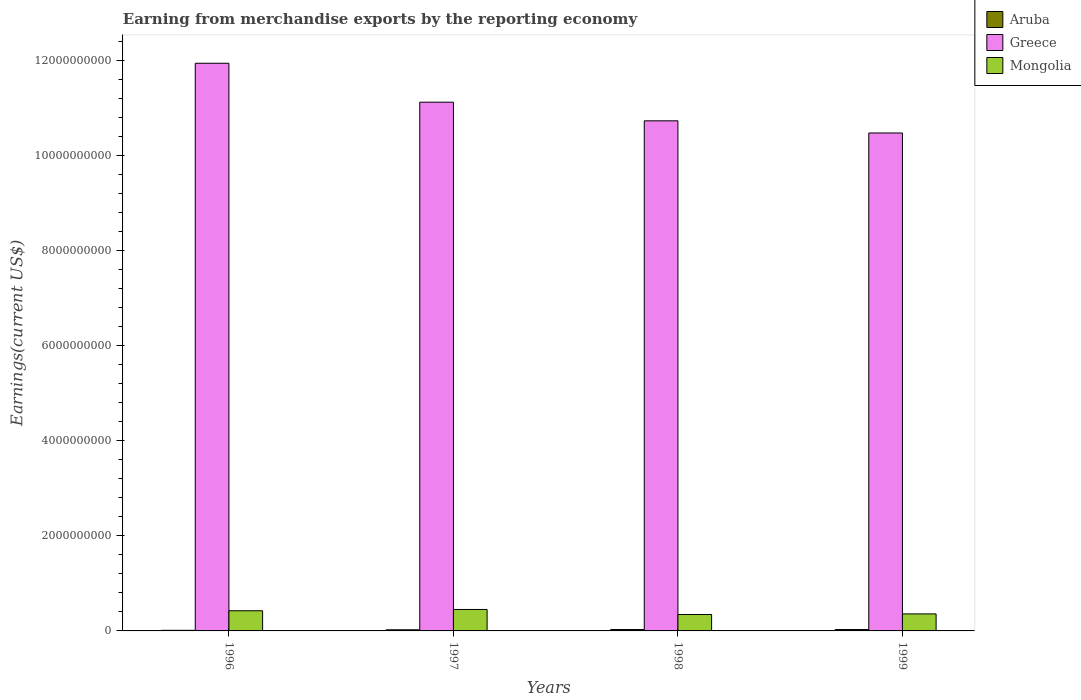Are the number of bars on each tick of the X-axis equal?
Your response must be concise. Yes. In how many cases, is the number of bars for a given year not equal to the number of legend labels?
Offer a terse response. 0. What is the amount earned from merchandise exports in Greece in 1999?
Keep it short and to the point. 1.05e+1. Across all years, what is the maximum amount earned from merchandise exports in Aruba?
Your response must be concise. 2.93e+07. Across all years, what is the minimum amount earned from merchandise exports in Mongolia?
Provide a short and direct response. 3.45e+08. What is the total amount earned from merchandise exports in Aruba in the graph?
Ensure brevity in your answer.  9.47e+07. What is the difference between the amount earned from merchandise exports in Aruba in 1996 and that in 1997?
Your answer should be very brief. -1.14e+07. What is the difference between the amount earned from merchandise exports in Aruba in 1998 and the amount earned from merchandise exports in Mongolia in 1999?
Ensure brevity in your answer.  -3.29e+08. What is the average amount earned from merchandise exports in Aruba per year?
Keep it short and to the point. 2.37e+07. In the year 1996, what is the difference between the amount earned from merchandise exports in Greece and amount earned from merchandise exports in Aruba?
Your answer should be compact. 1.19e+1. In how many years, is the amount earned from merchandise exports in Aruba greater than 1600000000 US$?
Ensure brevity in your answer.  0. What is the ratio of the amount earned from merchandise exports in Mongolia in 1996 to that in 1999?
Make the answer very short. 1.18. Is the difference between the amount earned from merchandise exports in Greece in 1996 and 1997 greater than the difference between the amount earned from merchandise exports in Aruba in 1996 and 1997?
Ensure brevity in your answer.  Yes. What is the difference between the highest and the second highest amount earned from merchandise exports in Mongolia?
Offer a terse response. 2.72e+07. What is the difference between the highest and the lowest amount earned from merchandise exports in Greece?
Keep it short and to the point. 1.47e+09. Is the sum of the amount earned from merchandise exports in Aruba in 1996 and 1997 greater than the maximum amount earned from merchandise exports in Greece across all years?
Your answer should be compact. No. What does the 2nd bar from the left in 1996 represents?
Make the answer very short. Greece. What does the 1st bar from the right in 1996 represents?
Ensure brevity in your answer.  Mongolia. How many bars are there?
Provide a succinct answer. 12. Are all the bars in the graph horizontal?
Your answer should be very brief. No. Are the values on the major ticks of Y-axis written in scientific E-notation?
Your answer should be very brief. No. How many legend labels are there?
Provide a short and direct response. 3. How are the legend labels stacked?
Provide a short and direct response. Vertical. What is the title of the graph?
Your response must be concise. Earning from merchandise exports by the reporting economy. Does "Kyrgyz Republic" appear as one of the legend labels in the graph?
Your response must be concise. No. What is the label or title of the Y-axis?
Keep it short and to the point. Earnings(current US$). What is the Earnings(current US$) of Aruba in 1996?
Your answer should be compact. 1.25e+07. What is the Earnings(current US$) of Greece in 1996?
Your response must be concise. 1.19e+1. What is the Earnings(current US$) in Mongolia in 1996?
Offer a very short reply. 4.24e+08. What is the Earnings(current US$) in Aruba in 1997?
Ensure brevity in your answer.  2.39e+07. What is the Earnings(current US$) in Greece in 1997?
Make the answer very short. 1.11e+1. What is the Earnings(current US$) in Mongolia in 1997?
Provide a short and direct response. 4.52e+08. What is the Earnings(current US$) in Aruba in 1998?
Your answer should be compact. 2.90e+07. What is the Earnings(current US$) of Greece in 1998?
Keep it short and to the point. 1.07e+1. What is the Earnings(current US$) of Mongolia in 1998?
Keep it short and to the point. 3.45e+08. What is the Earnings(current US$) of Aruba in 1999?
Your answer should be very brief. 2.93e+07. What is the Earnings(current US$) in Greece in 1999?
Give a very brief answer. 1.05e+1. What is the Earnings(current US$) in Mongolia in 1999?
Provide a short and direct response. 3.58e+08. Across all years, what is the maximum Earnings(current US$) of Aruba?
Your answer should be very brief. 2.93e+07. Across all years, what is the maximum Earnings(current US$) in Greece?
Provide a short and direct response. 1.19e+1. Across all years, what is the maximum Earnings(current US$) of Mongolia?
Offer a very short reply. 4.52e+08. Across all years, what is the minimum Earnings(current US$) of Aruba?
Offer a terse response. 1.25e+07. Across all years, what is the minimum Earnings(current US$) of Greece?
Give a very brief answer. 1.05e+1. Across all years, what is the minimum Earnings(current US$) of Mongolia?
Your answer should be very brief. 3.45e+08. What is the total Earnings(current US$) of Aruba in the graph?
Keep it short and to the point. 9.47e+07. What is the total Earnings(current US$) in Greece in the graph?
Provide a short and direct response. 4.43e+1. What is the total Earnings(current US$) in Mongolia in the graph?
Give a very brief answer. 1.58e+09. What is the difference between the Earnings(current US$) of Aruba in 1996 and that in 1997?
Provide a short and direct response. -1.14e+07. What is the difference between the Earnings(current US$) in Greece in 1996 and that in 1997?
Keep it short and to the point. 8.19e+08. What is the difference between the Earnings(current US$) of Mongolia in 1996 and that in 1997?
Provide a succinct answer. -2.72e+07. What is the difference between the Earnings(current US$) of Aruba in 1996 and that in 1998?
Your answer should be very brief. -1.65e+07. What is the difference between the Earnings(current US$) of Greece in 1996 and that in 1998?
Ensure brevity in your answer.  1.21e+09. What is the difference between the Earnings(current US$) of Mongolia in 1996 and that in 1998?
Ensure brevity in your answer.  7.92e+07. What is the difference between the Earnings(current US$) in Aruba in 1996 and that in 1999?
Ensure brevity in your answer.  -1.67e+07. What is the difference between the Earnings(current US$) in Greece in 1996 and that in 1999?
Make the answer very short. 1.47e+09. What is the difference between the Earnings(current US$) in Mongolia in 1996 and that in 1999?
Give a very brief answer. 6.60e+07. What is the difference between the Earnings(current US$) of Aruba in 1997 and that in 1998?
Give a very brief answer. -5.09e+06. What is the difference between the Earnings(current US$) of Greece in 1997 and that in 1998?
Ensure brevity in your answer.  3.92e+08. What is the difference between the Earnings(current US$) in Mongolia in 1997 and that in 1998?
Keep it short and to the point. 1.06e+08. What is the difference between the Earnings(current US$) in Aruba in 1997 and that in 1999?
Ensure brevity in your answer.  -5.35e+06. What is the difference between the Earnings(current US$) in Greece in 1997 and that in 1999?
Give a very brief answer. 6.49e+08. What is the difference between the Earnings(current US$) of Mongolia in 1997 and that in 1999?
Offer a very short reply. 9.32e+07. What is the difference between the Earnings(current US$) in Aruba in 1998 and that in 1999?
Offer a very short reply. -2.66e+05. What is the difference between the Earnings(current US$) of Greece in 1998 and that in 1999?
Provide a short and direct response. 2.56e+08. What is the difference between the Earnings(current US$) in Mongolia in 1998 and that in 1999?
Ensure brevity in your answer.  -1.32e+07. What is the difference between the Earnings(current US$) in Aruba in 1996 and the Earnings(current US$) in Greece in 1997?
Ensure brevity in your answer.  -1.11e+1. What is the difference between the Earnings(current US$) of Aruba in 1996 and the Earnings(current US$) of Mongolia in 1997?
Your response must be concise. -4.39e+08. What is the difference between the Earnings(current US$) of Greece in 1996 and the Earnings(current US$) of Mongolia in 1997?
Ensure brevity in your answer.  1.15e+1. What is the difference between the Earnings(current US$) of Aruba in 1996 and the Earnings(current US$) of Greece in 1998?
Offer a terse response. -1.07e+1. What is the difference between the Earnings(current US$) in Aruba in 1996 and the Earnings(current US$) in Mongolia in 1998?
Offer a very short reply. -3.33e+08. What is the difference between the Earnings(current US$) in Greece in 1996 and the Earnings(current US$) in Mongolia in 1998?
Give a very brief answer. 1.16e+1. What is the difference between the Earnings(current US$) in Aruba in 1996 and the Earnings(current US$) in Greece in 1999?
Your response must be concise. -1.05e+1. What is the difference between the Earnings(current US$) in Aruba in 1996 and the Earnings(current US$) in Mongolia in 1999?
Give a very brief answer. -3.46e+08. What is the difference between the Earnings(current US$) in Greece in 1996 and the Earnings(current US$) in Mongolia in 1999?
Provide a succinct answer. 1.16e+1. What is the difference between the Earnings(current US$) of Aruba in 1997 and the Earnings(current US$) of Greece in 1998?
Give a very brief answer. -1.07e+1. What is the difference between the Earnings(current US$) in Aruba in 1997 and the Earnings(current US$) in Mongolia in 1998?
Make the answer very short. -3.21e+08. What is the difference between the Earnings(current US$) of Greece in 1997 and the Earnings(current US$) of Mongolia in 1998?
Ensure brevity in your answer.  1.08e+1. What is the difference between the Earnings(current US$) of Aruba in 1997 and the Earnings(current US$) of Greece in 1999?
Make the answer very short. -1.05e+1. What is the difference between the Earnings(current US$) in Aruba in 1997 and the Earnings(current US$) in Mongolia in 1999?
Keep it short and to the point. -3.34e+08. What is the difference between the Earnings(current US$) of Greece in 1997 and the Earnings(current US$) of Mongolia in 1999?
Give a very brief answer. 1.08e+1. What is the difference between the Earnings(current US$) in Aruba in 1998 and the Earnings(current US$) in Greece in 1999?
Your answer should be compact. -1.05e+1. What is the difference between the Earnings(current US$) in Aruba in 1998 and the Earnings(current US$) in Mongolia in 1999?
Keep it short and to the point. -3.29e+08. What is the difference between the Earnings(current US$) of Greece in 1998 and the Earnings(current US$) of Mongolia in 1999?
Give a very brief answer. 1.04e+1. What is the average Earnings(current US$) of Aruba per year?
Make the answer very short. 2.37e+07. What is the average Earnings(current US$) of Greece per year?
Keep it short and to the point. 1.11e+1. What is the average Earnings(current US$) in Mongolia per year?
Make the answer very short. 3.95e+08. In the year 1996, what is the difference between the Earnings(current US$) of Aruba and Earnings(current US$) of Greece?
Your answer should be very brief. -1.19e+1. In the year 1996, what is the difference between the Earnings(current US$) of Aruba and Earnings(current US$) of Mongolia?
Your answer should be very brief. -4.12e+08. In the year 1996, what is the difference between the Earnings(current US$) in Greece and Earnings(current US$) in Mongolia?
Provide a short and direct response. 1.15e+1. In the year 1997, what is the difference between the Earnings(current US$) in Aruba and Earnings(current US$) in Greece?
Make the answer very short. -1.11e+1. In the year 1997, what is the difference between the Earnings(current US$) of Aruba and Earnings(current US$) of Mongolia?
Keep it short and to the point. -4.28e+08. In the year 1997, what is the difference between the Earnings(current US$) in Greece and Earnings(current US$) in Mongolia?
Provide a succinct answer. 1.07e+1. In the year 1998, what is the difference between the Earnings(current US$) of Aruba and Earnings(current US$) of Greece?
Offer a terse response. -1.07e+1. In the year 1998, what is the difference between the Earnings(current US$) of Aruba and Earnings(current US$) of Mongolia?
Keep it short and to the point. -3.16e+08. In the year 1998, what is the difference between the Earnings(current US$) in Greece and Earnings(current US$) in Mongolia?
Provide a short and direct response. 1.04e+1. In the year 1999, what is the difference between the Earnings(current US$) in Aruba and Earnings(current US$) in Greece?
Make the answer very short. -1.05e+1. In the year 1999, what is the difference between the Earnings(current US$) of Aruba and Earnings(current US$) of Mongolia?
Offer a terse response. -3.29e+08. In the year 1999, what is the difference between the Earnings(current US$) in Greece and Earnings(current US$) in Mongolia?
Offer a very short reply. 1.01e+1. What is the ratio of the Earnings(current US$) of Aruba in 1996 to that in 1997?
Provide a succinct answer. 0.52. What is the ratio of the Earnings(current US$) in Greece in 1996 to that in 1997?
Provide a succinct answer. 1.07. What is the ratio of the Earnings(current US$) in Mongolia in 1996 to that in 1997?
Offer a terse response. 0.94. What is the ratio of the Earnings(current US$) of Aruba in 1996 to that in 1998?
Ensure brevity in your answer.  0.43. What is the ratio of the Earnings(current US$) in Greece in 1996 to that in 1998?
Provide a succinct answer. 1.11. What is the ratio of the Earnings(current US$) in Mongolia in 1996 to that in 1998?
Your answer should be very brief. 1.23. What is the ratio of the Earnings(current US$) in Aruba in 1996 to that in 1999?
Offer a very short reply. 0.43. What is the ratio of the Earnings(current US$) of Greece in 1996 to that in 1999?
Your answer should be compact. 1.14. What is the ratio of the Earnings(current US$) in Mongolia in 1996 to that in 1999?
Give a very brief answer. 1.18. What is the ratio of the Earnings(current US$) in Aruba in 1997 to that in 1998?
Your answer should be compact. 0.82. What is the ratio of the Earnings(current US$) of Greece in 1997 to that in 1998?
Make the answer very short. 1.04. What is the ratio of the Earnings(current US$) in Mongolia in 1997 to that in 1998?
Your answer should be compact. 1.31. What is the ratio of the Earnings(current US$) of Aruba in 1997 to that in 1999?
Make the answer very short. 0.82. What is the ratio of the Earnings(current US$) of Greece in 1997 to that in 1999?
Your answer should be very brief. 1.06. What is the ratio of the Earnings(current US$) of Mongolia in 1997 to that in 1999?
Your response must be concise. 1.26. What is the ratio of the Earnings(current US$) in Aruba in 1998 to that in 1999?
Provide a succinct answer. 0.99. What is the ratio of the Earnings(current US$) in Greece in 1998 to that in 1999?
Provide a short and direct response. 1.02. What is the ratio of the Earnings(current US$) of Mongolia in 1998 to that in 1999?
Your response must be concise. 0.96. What is the difference between the highest and the second highest Earnings(current US$) of Aruba?
Your answer should be compact. 2.66e+05. What is the difference between the highest and the second highest Earnings(current US$) of Greece?
Your answer should be compact. 8.19e+08. What is the difference between the highest and the second highest Earnings(current US$) of Mongolia?
Ensure brevity in your answer.  2.72e+07. What is the difference between the highest and the lowest Earnings(current US$) in Aruba?
Your answer should be very brief. 1.67e+07. What is the difference between the highest and the lowest Earnings(current US$) of Greece?
Make the answer very short. 1.47e+09. What is the difference between the highest and the lowest Earnings(current US$) of Mongolia?
Give a very brief answer. 1.06e+08. 